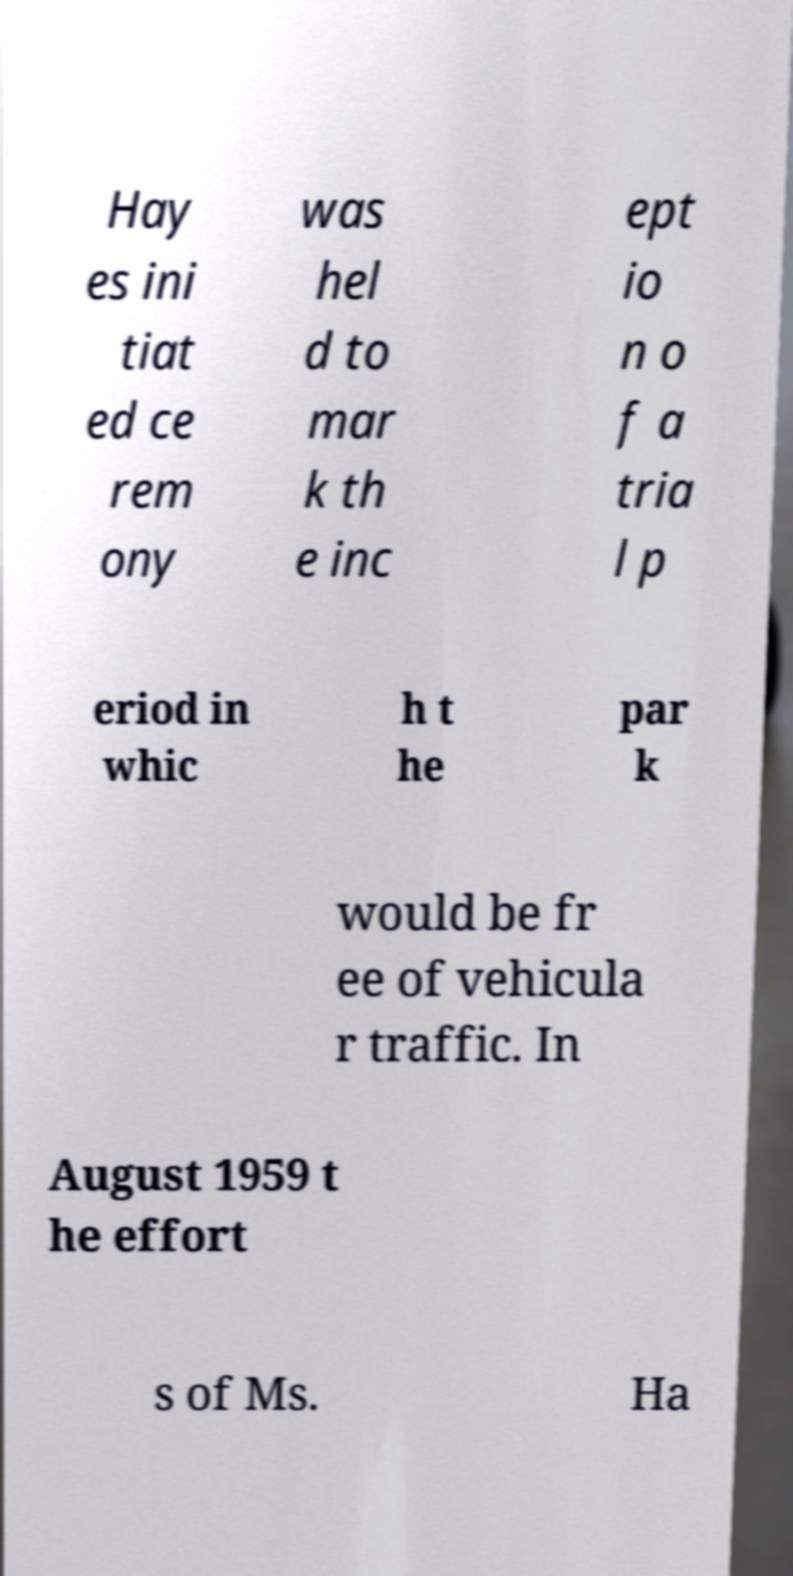Can you read and provide the text displayed in the image?This photo seems to have some interesting text. Can you extract and type it out for me? Hay es ini tiat ed ce rem ony was hel d to mar k th e inc ept io n o f a tria l p eriod in whic h t he par k would be fr ee of vehicula r traffic. In August 1959 t he effort s of Ms. Ha 